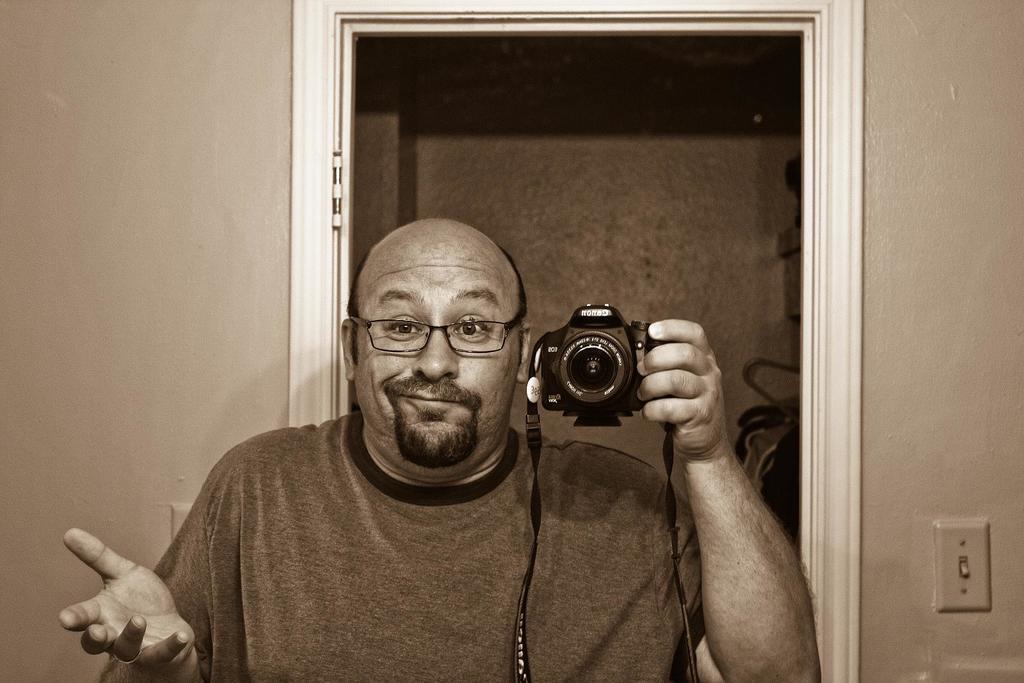Describe this image in one or two sentences. A person is taking a picture of himself,holding a camera in his hand. 